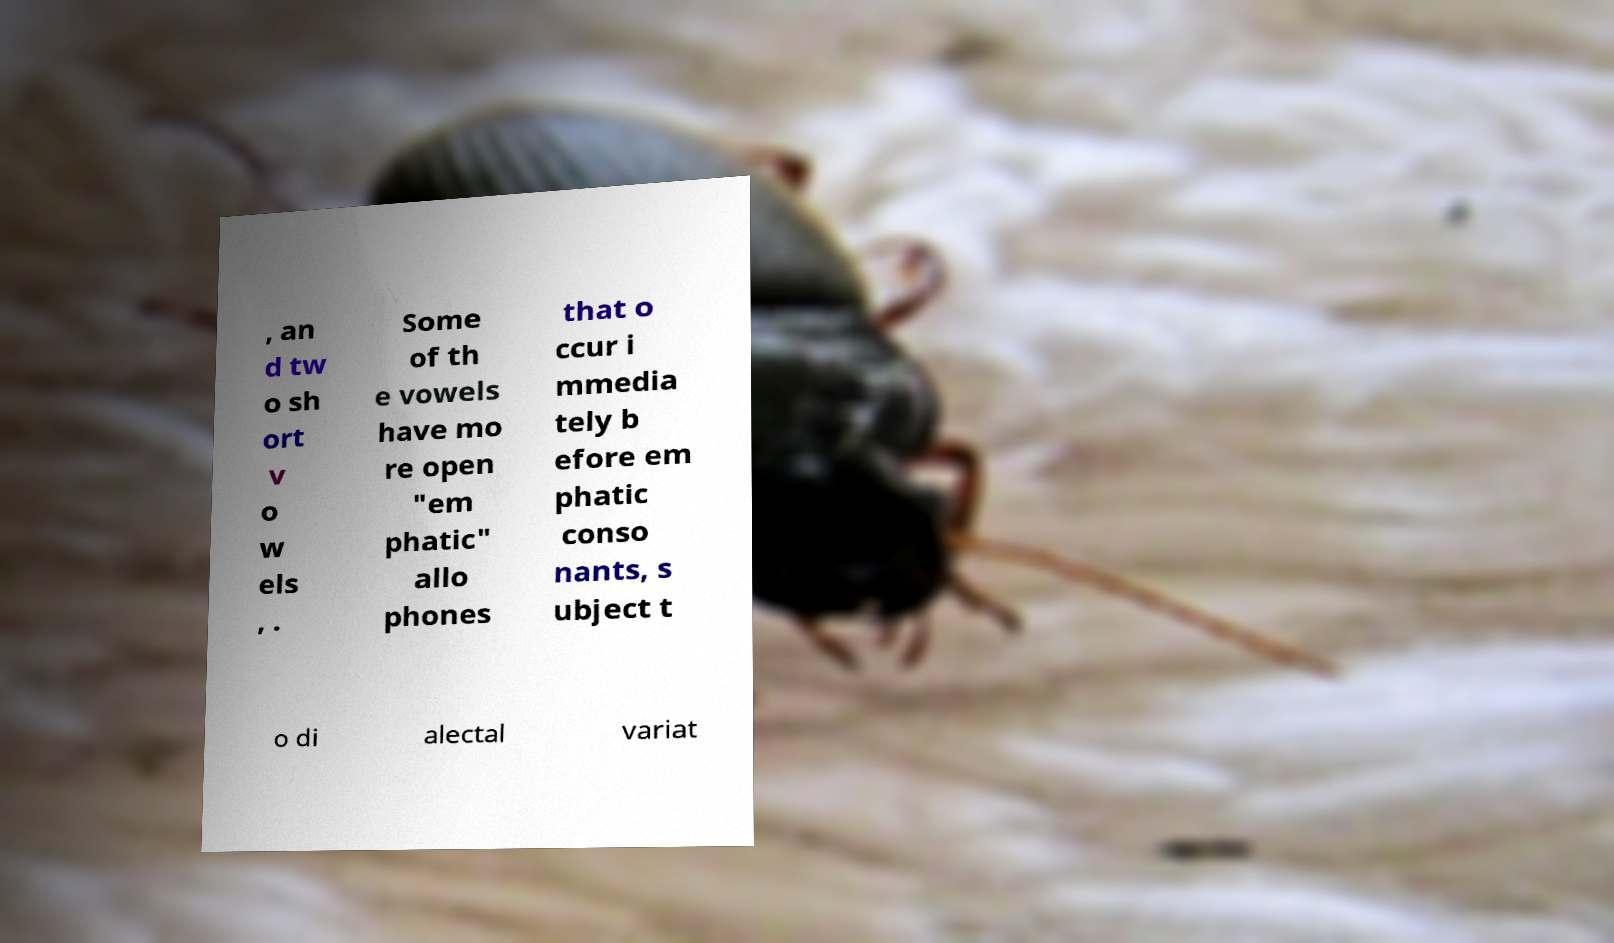Please read and relay the text visible in this image. What does it say? , an d tw o sh ort v o w els , . Some of th e vowels have mo re open "em phatic" allo phones that o ccur i mmedia tely b efore em phatic conso nants, s ubject t o di alectal variat 